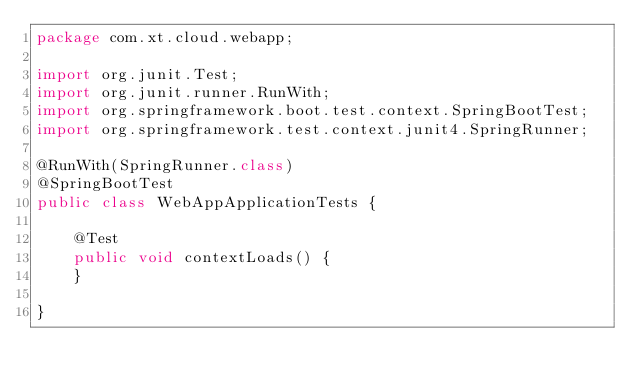<code> <loc_0><loc_0><loc_500><loc_500><_Java_>package com.xt.cloud.webapp;

import org.junit.Test;
import org.junit.runner.RunWith;
import org.springframework.boot.test.context.SpringBootTest;
import org.springframework.test.context.junit4.SpringRunner;

@RunWith(SpringRunner.class)
@SpringBootTest
public class WebAppApplicationTests {

	@Test
	public void contextLoads() {
	}

}
</code> 